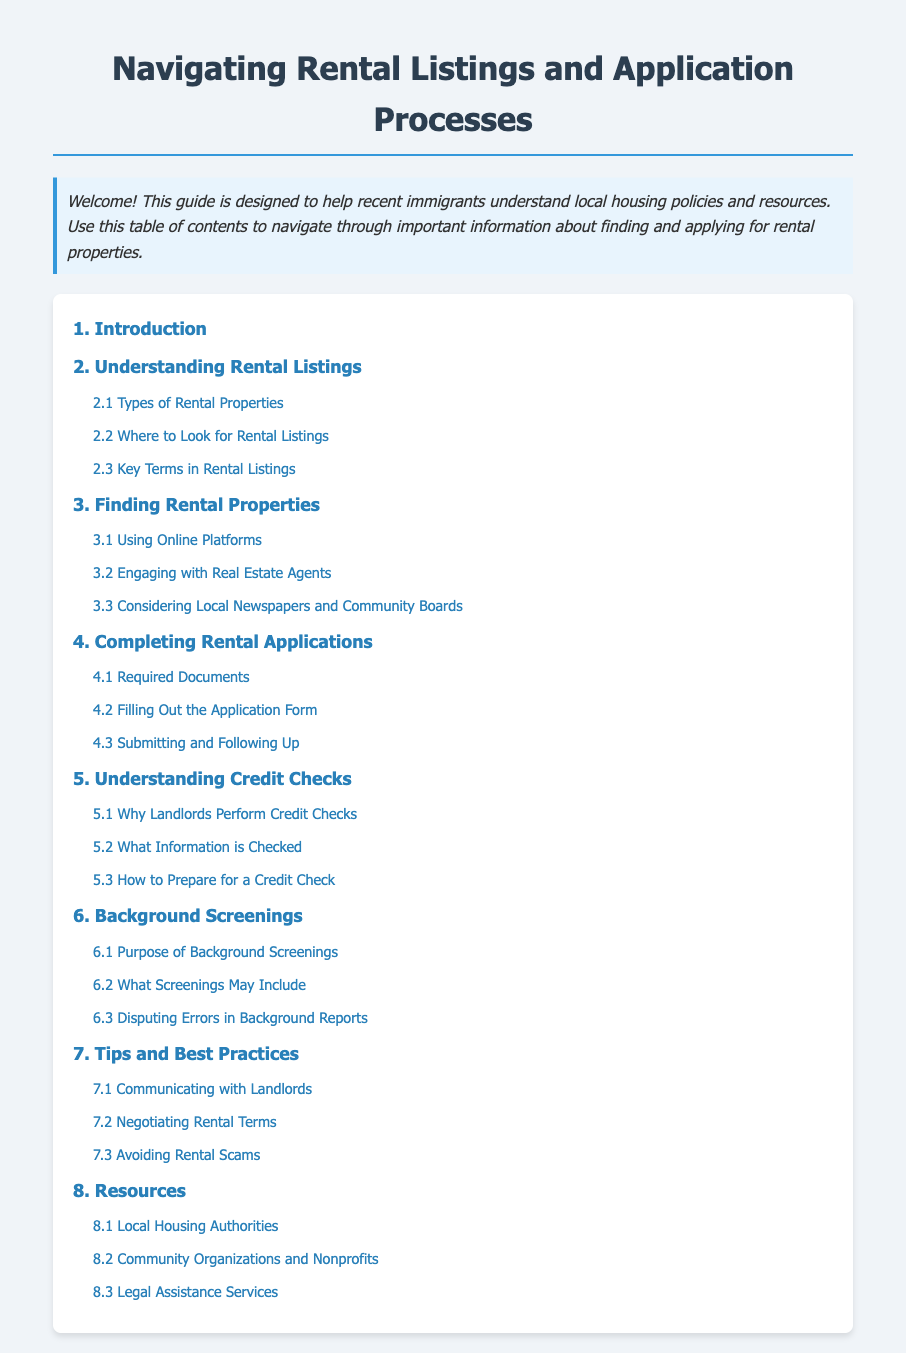What is the title of the document? The title of the document is prominently displayed at the top and states its purpose.
Answer: Navigating Rental Listings and Application Processes How many main sections are in the table of contents? The table of contents lists the main sections, which are counted for the total number.
Answer: 8 What is the first sub-section under "Understanding Rental Listings"? The sub-section provides specific details under the main section regarding rental listings.
Answer: Types of Rental Properties Which section covers "Submitting and Following Up"? This section relates to the application process, indicating important steps to take after applying.
Answer: Completing Rental Applications What is one purpose of Background Screenings? This question requires understanding the document’s content regarding background checks.
Answer: Purpose of Background Screenings What document section includes legal assistance services? This section specifically addresses resources available for legal help related to housing.
Answer: Resources What is the last section listed in the table of contents? The last section indicates the final area of information covered in the document.
Answer: Resources How many sub-sections are under "Tips and Best Practices"? This question requires counting the sub-sections related to best practices.
Answer: 3 